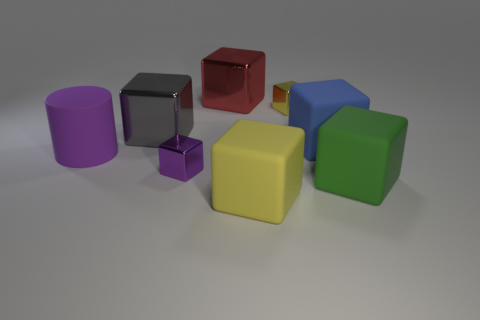Does the tiny block in front of the large blue cube have the same color as the big cylinder?
Offer a very short reply. Yes. How many other objects are there of the same color as the rubber cylinder?
Offer a very short reply. 1. Is the color of the small block behind the blue rubber object the same as the big matte cube that is on the left side of the blue thing?
Make the answer very short. Yes. There is a yellow cube that is the same size as the green block; what material is it?
Ensure brevity in your answer.  Rubber. There is a big object in front of the green rubber block; what shape is it?
Offer a very short reply. Cube. Do the thing to the left of the gray block and the yellow thing that is in front of the big matte cylinder have the same material?
Give a very brief answer. Yes. What number of purple things are the same shape as the green matte thing?
Provide a short and direct response. 1. There is a tiny thing that is the same color as the cylinder; what is it made of?
Provide a succinct answer. Metal. How many objects are small purple metallic blocks or yellow things behind the purple metallic cube?
Offer a very short reply. 2. What material is the big red cube?
Offer a terse response. Metal. 